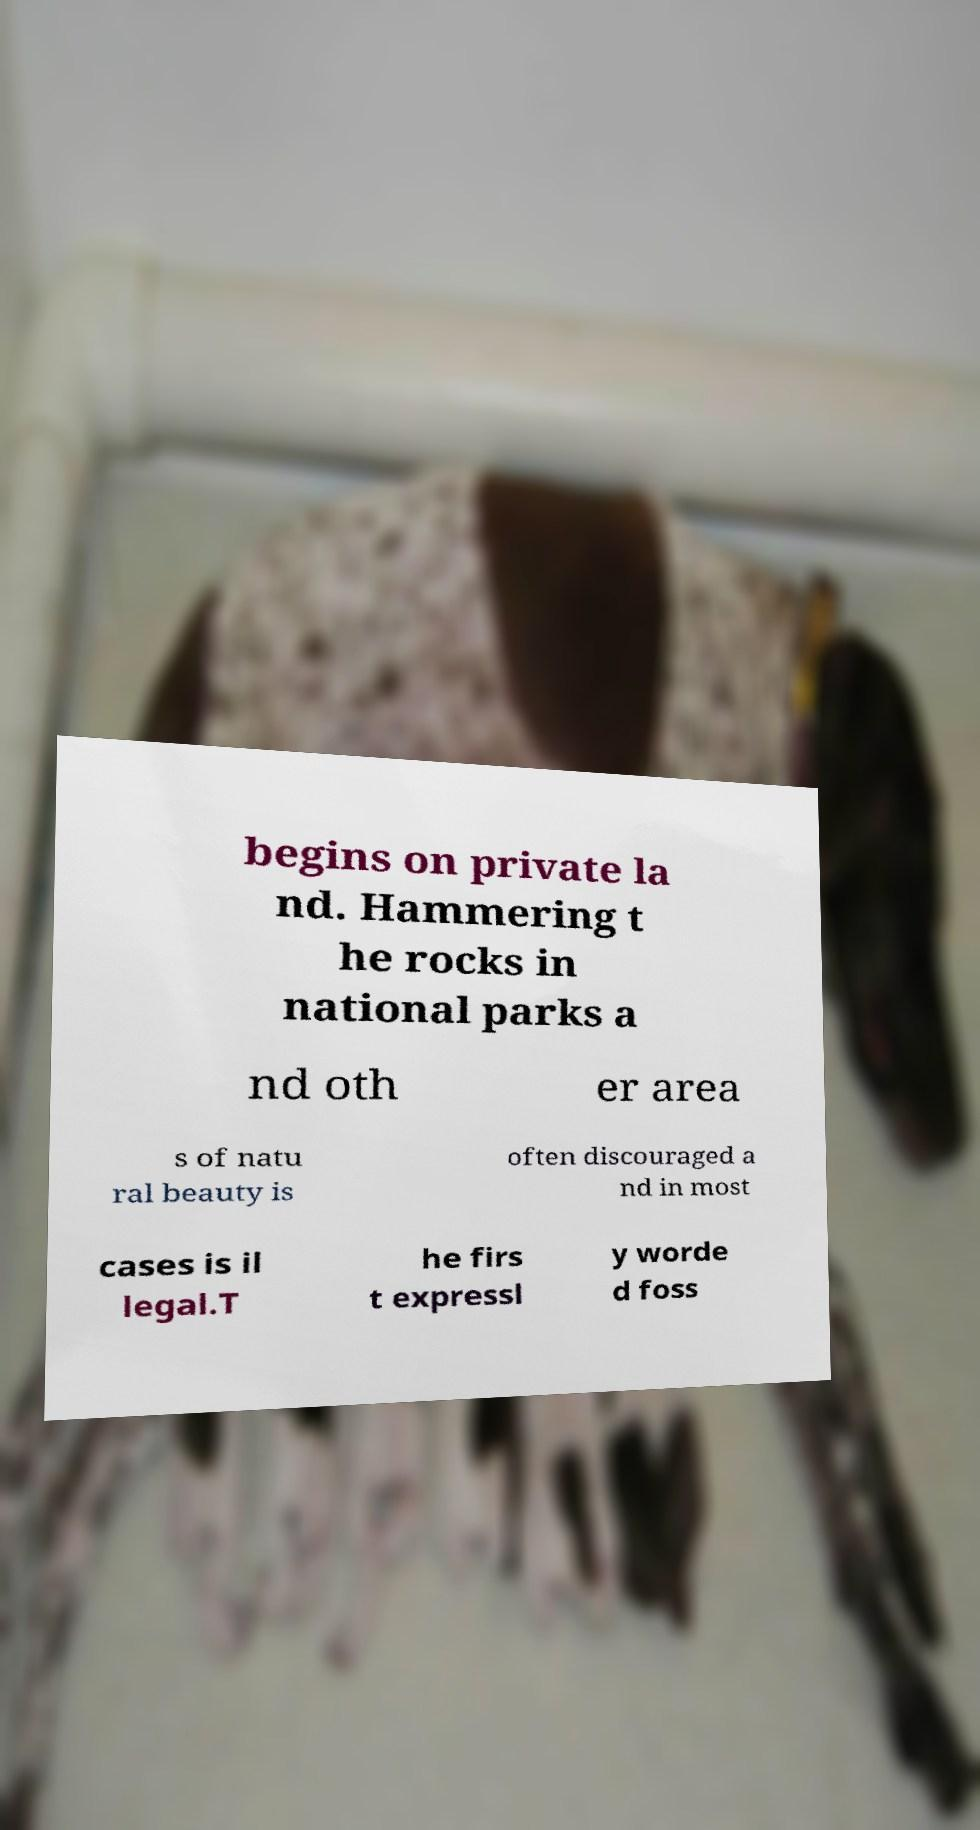Can you read and provide the text displayed in the image?This photo seems to have some interesting text. Can you extract and type it out for me? begins on private la nd. Hammering t he rocks in national parks a nd oth er area s of natu ral beauty is often discouraged a nd in most cases is il legal.T he firs t expressl y worde d foss 